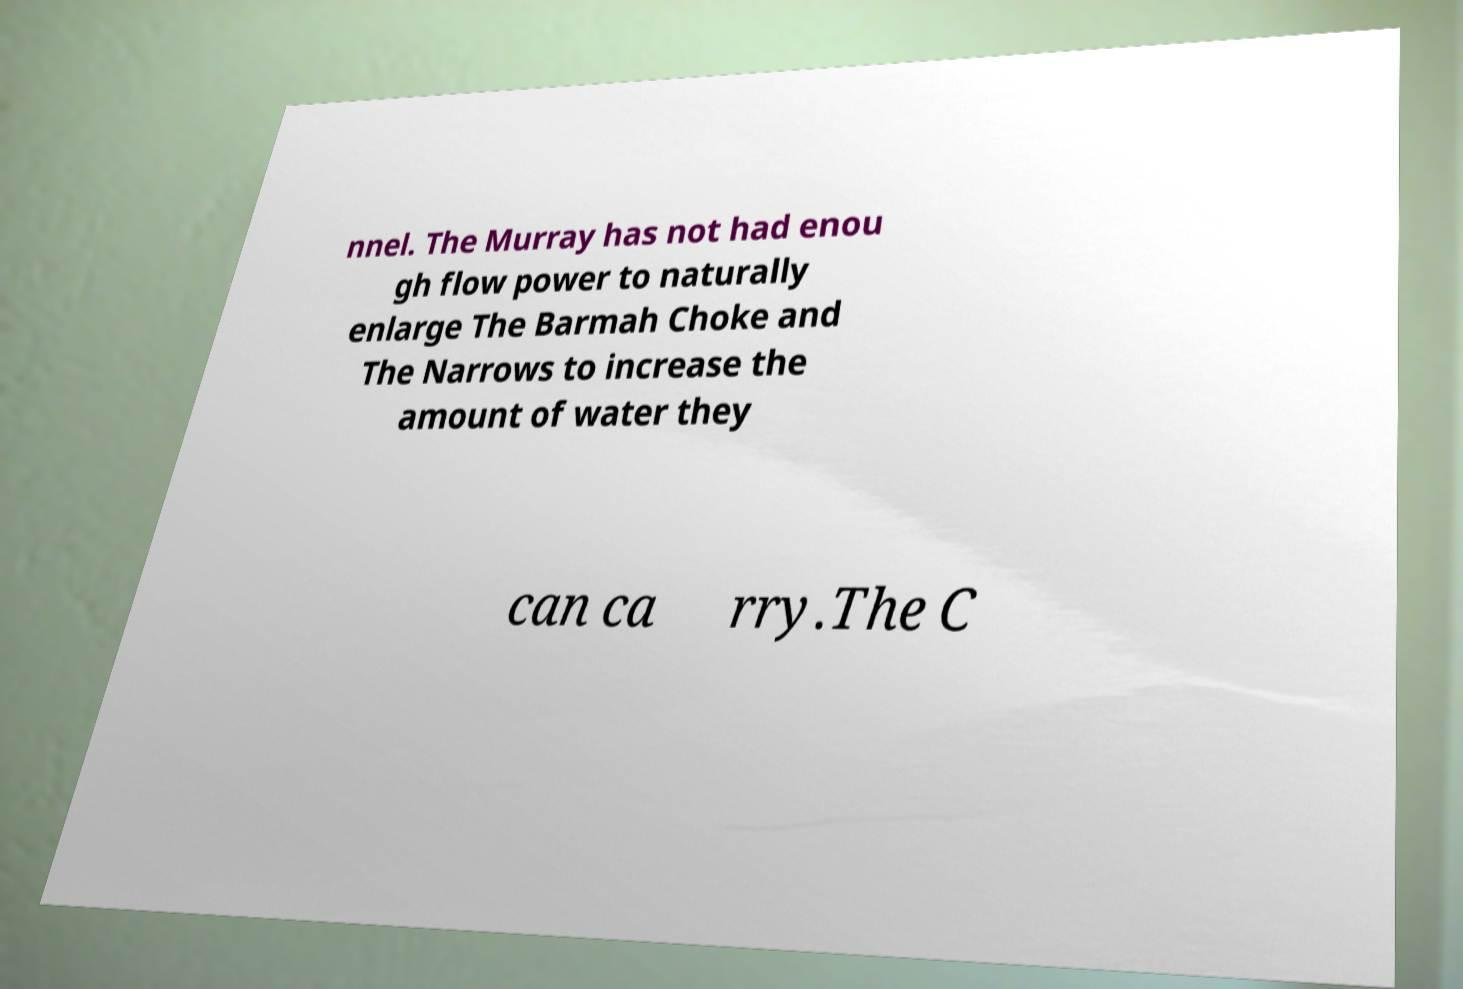Please identify and transcribe the text found in this image. nnel. The Murray has not had enou gh flow power to naturally enlarge The Barmah Choke and The Narrows to increase the amount of water they can ca rry.The C 